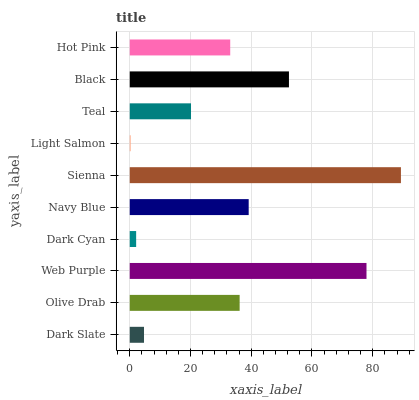Is Light Salmon the minimum?
Answer yes or no. Yes. Is Sienna the maximum?
Answer yes or no. Yes. Is Olive Drab the minimum?
Answer yes or no. No. Is Olive Drab the maximum?
Answer yes or no. No. Is Olive Drab greater than Dark Slate?
Answer yes or no. Yes. Is Dark Slate less than Olive Drab?
Answer yes or no. Yes. Is Dark Slate greater than Olive Drab?
Answer yes or no. No. Is Olive Drab less than Dark Slate?
Answer yes or no. No. Is Olive Drab the high median?
Answer yes or no. Yes. Is Hot Pink the low median?
Answer yes or no. Yes. Is Black the high median?
Answer yes or no. No. Is Dark Cyan the low median?
Answer yes or no. No. 